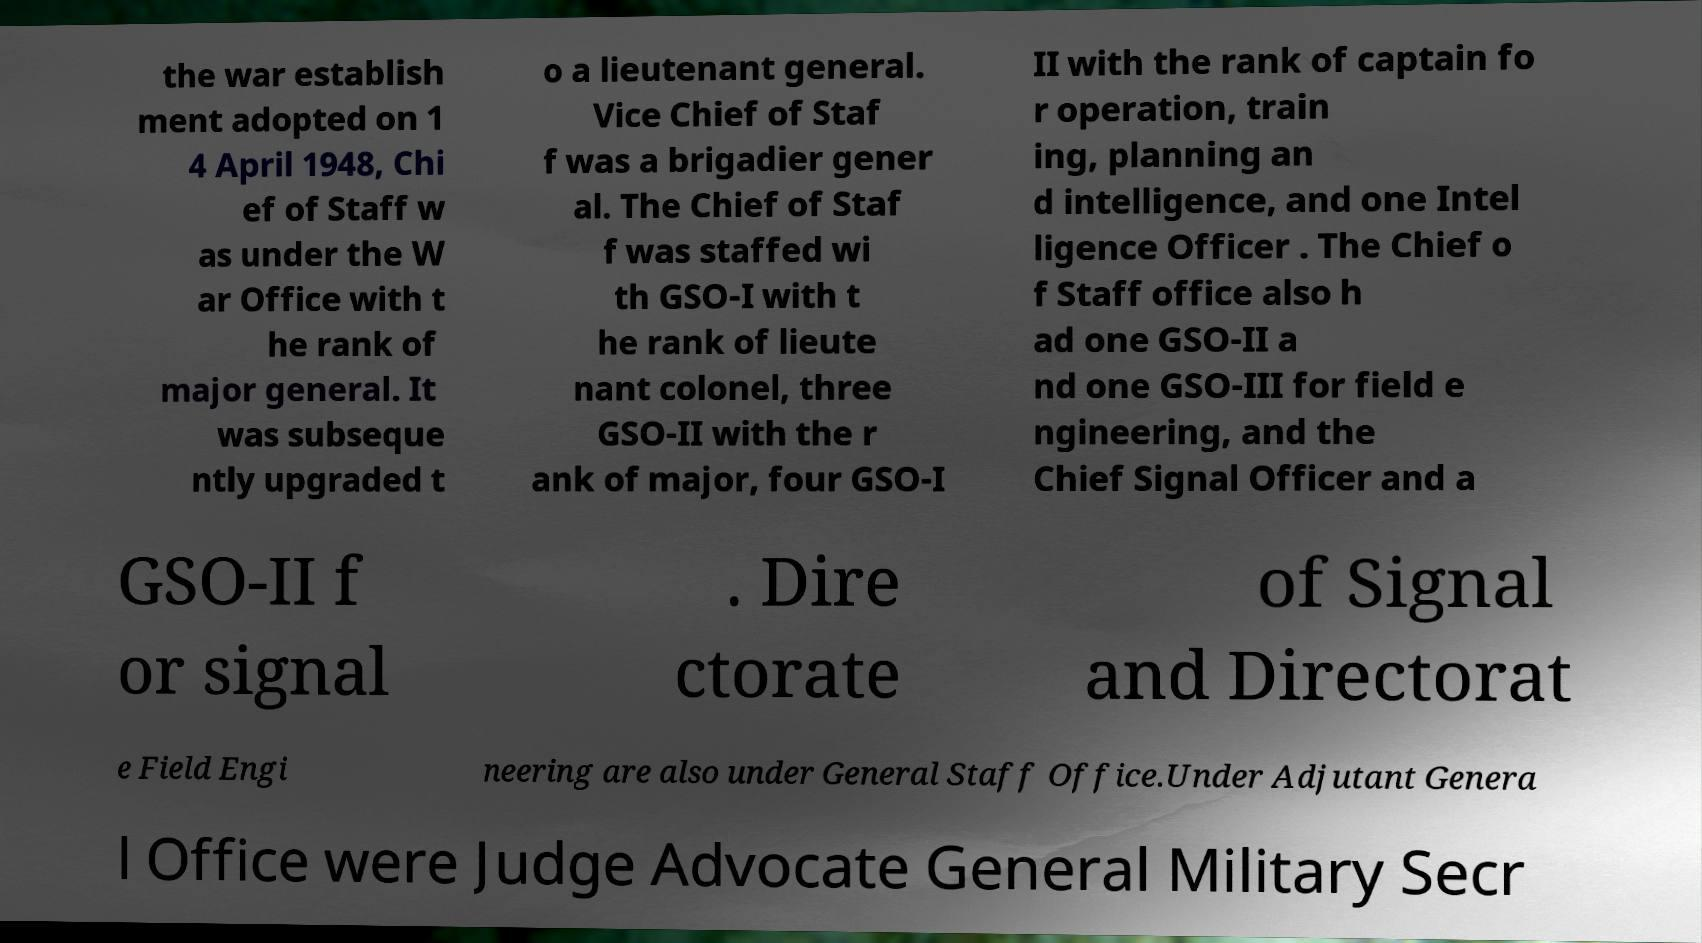Can you read and provide the text displayed in the image?This photo seems to have some interesting text. Can you extract and type it out for me? the war establish ment adopted on 1 4 April 1948, Chi ef of Staff w as under the W ar Office with t he rank of major general. It was subseque ntly upgraded t o a lieutenant general. Vice Chief of Staf f was a brigadier gener al. The Chief of Staf f was staffed wi th GSO-I with t he rank of lieute nant colonel, three GSO-II with the r ank of major, four GSO-I II with the rank of captain fo r operation, train ing, planning an d intelligence, and one Intel ligence Officer . The Chief o f Staff office also h ad one GSO-II a nd one GSO-III for field e ngineering, and the Chief Signal Officer and a GSO-II f or signal . Dire ctorate of Signal and Directorat e Field Engi neering are also under General Staff Office.Under Adjutant Genera l Office were Judge Advocate General Military Secr 